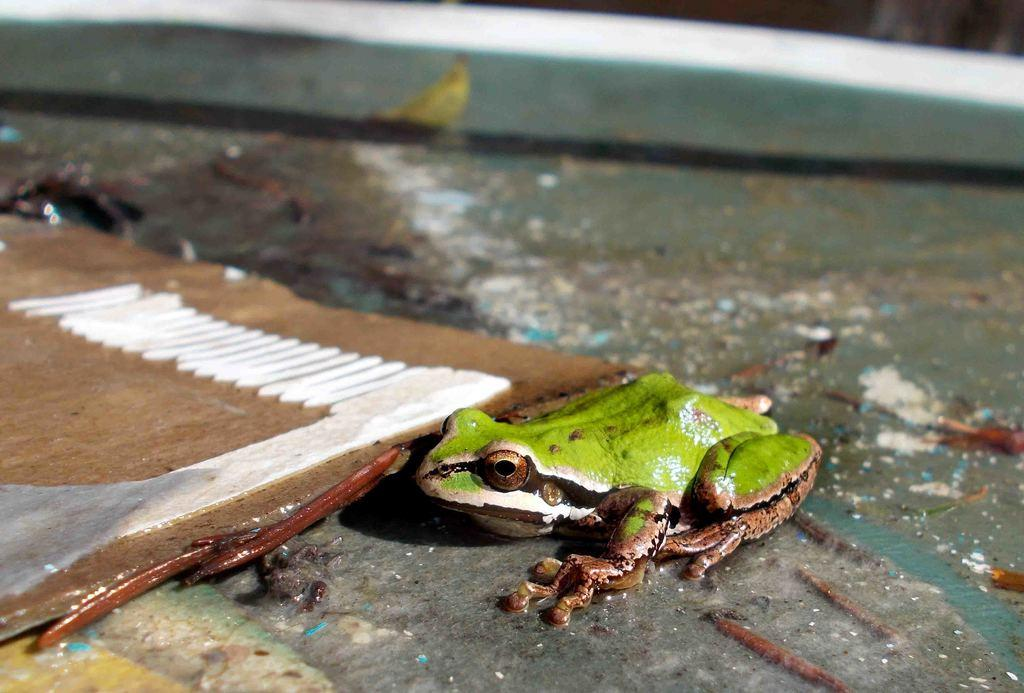What type of animal is in the image? There is a green and brown color frog in the image. What else can be seen in the image besides the frog? There is a brown and white color board in the image. Can you describe the background of the image? The background of the image is blurred. How many toys are on the wing in the image? There are no toys or wings present in the image. 